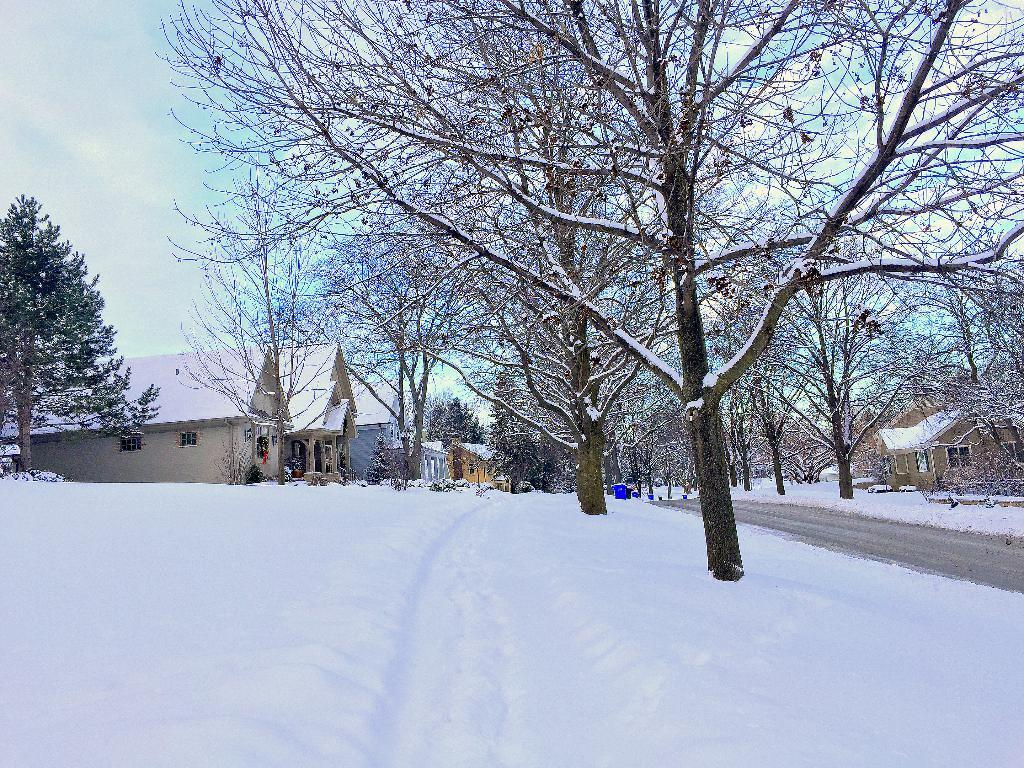What is the predominant weather condition in the image? There is snow in the image, indicating a cold and wintry weather condition. What type of natural elements can be seen in the image? There are trees in the image. What man-made structures are present in the image? Dustbins, a road, and houses are visible in the image. What can be seen in the background of the image? The sky is visible in the background of the image. What type of legal advice is the lawyer providing in the image? There is no lawyer present in the image, so it is not possible to determine what type of legal advice might be provided. 